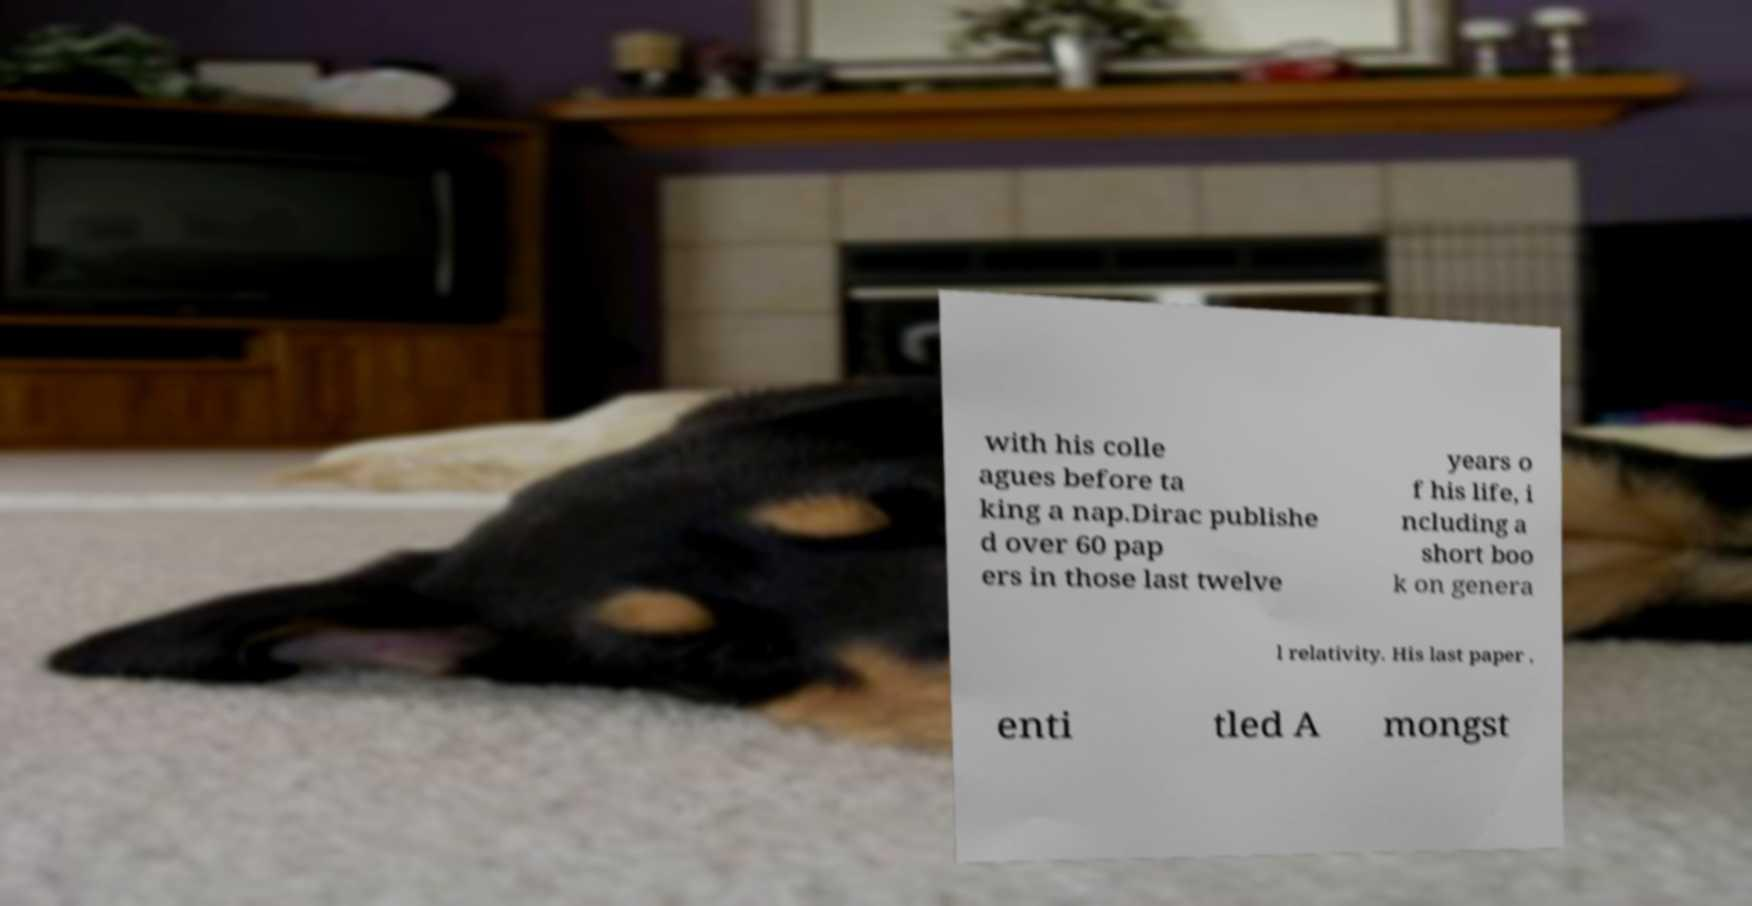Could you assist in decoding the text presented in this image and type it out clearly? with his colle agues before ta king a nap.Dirac publishe d over 60 pap ers in those last twelve years o f his life, i ncluding a short boo k on genera l relativity. His last paper , enti tled A mongst 